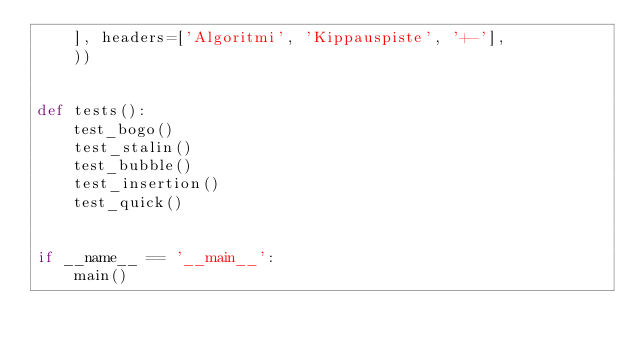<code> <loc_0><loc_0><loc_500><loc_500><_Python_>    ], headers=['Algoritmi', 'Kippauspiste', '+-'],
    ))


def tests():
    test_bogo()
    test_stalin()
    test_bubble()
    test_insertion()
    test_quick()


if __name__ == '__main__':
    main()
</code> 